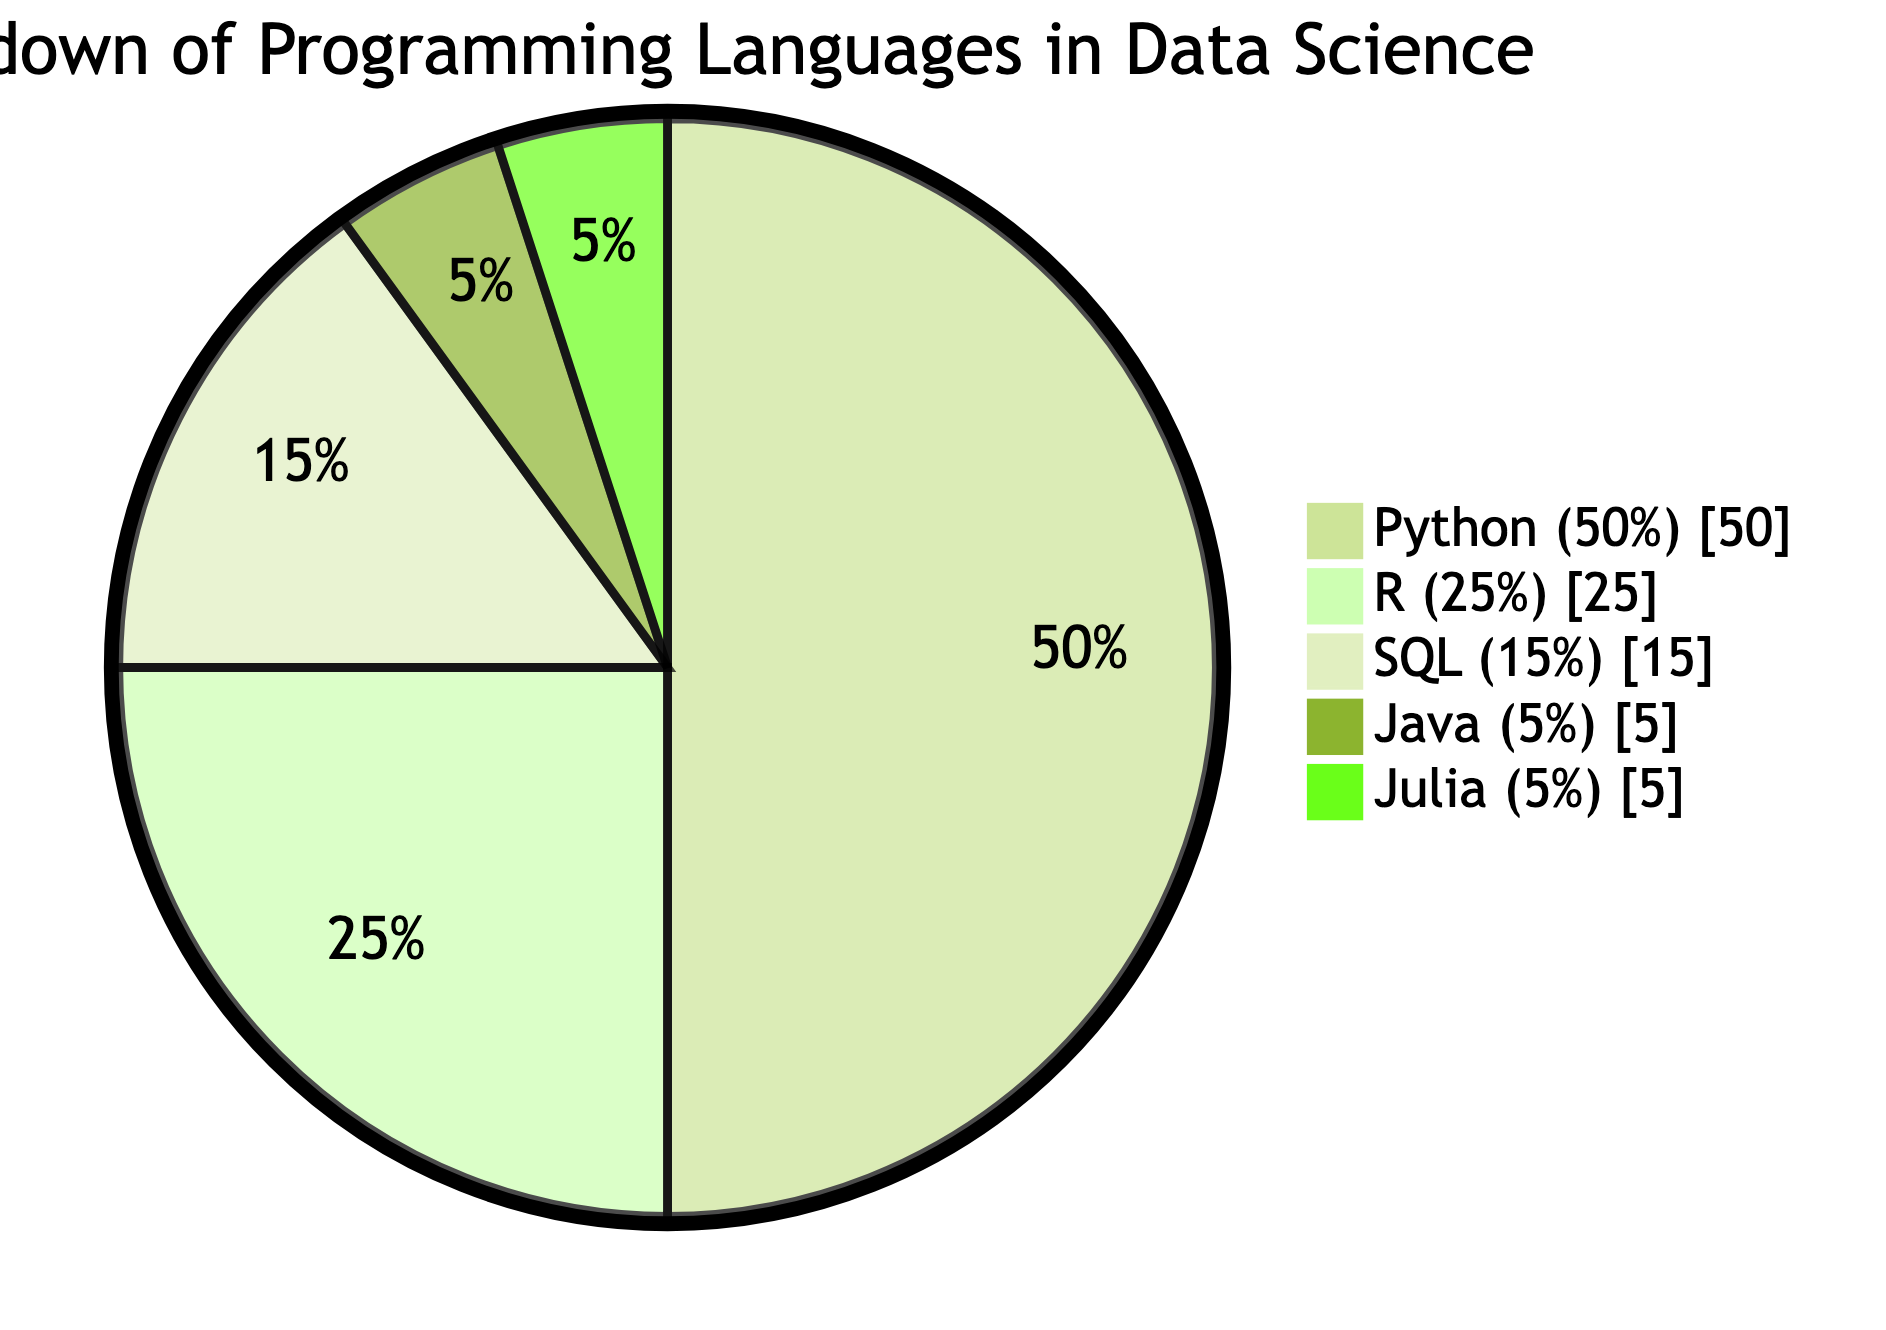What is the percentage of Python used in data science? The diagram specifies that Python occupies 50% of the pie chart, which clearly indicates its share in the breakdown of programming languages used in data science.
Answer: 50% Which programming language has the smallest share in data science? By examining the pie chart, it can be seen that both Java and Julia share the smallest percentage at 5%, indicating that they are each represented equally in this breakdown.
Answer: Java and Julia How many programming languages are represented in the diagram? The pie chart depicts five distinct segments, each corresponding to a different programming language used in data science, thus providing a total count of five.
Answer: 5 What is the combined percentage of SQL and R in this breakdown? Adding the individual percentages shown in the pie for SQL (15%) and R (25%) gives a total of 40%, representing their combined contribution in the analysis of programming languages for data science.
Answer: 40% What programming language comprises a quarter of the diagram? The pie chart indicates that R occupies 25% of the total, which is exactly one quarter, reflecting its significant role among the programming languages illustrated.
Answer: R Which two programming languages have equal representation? The chart shows that both Java and Julia are represented at 5% each, indicating an equal contribution from these programming languages in the data science landscape.
Answer: Java and Julia What is the most common programming language used in data science according to the diagram? The largest segment of the pie chart is occupied by Python at 50%, confirming its status as the most commonly used programming language in the field of data science as depicted in this breakdown.
Answer: Python What is the total percentage accounted for by Python, R, and SQL combined? Adding the percentages for Python (50%), R (25%), and SQL (15%) results in a total of 90%, indicating the substantial contribution of these three languages to the overall data science programming landscape.
Answer: 90% 